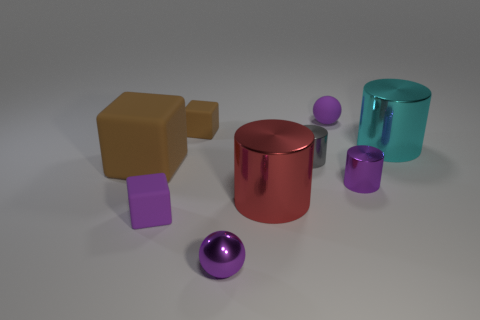Are there any large red metal cylinders on the right side of the purple rubber ball? After carefully observing the image, it is confirmed that there are no large red metal cylinders to the right of the purple rubber ball. Instead, the objects present in that area include a red metal cylinder, but it is alongside the ball, not on what would be considered the 'right' side if facing the ball directly. 